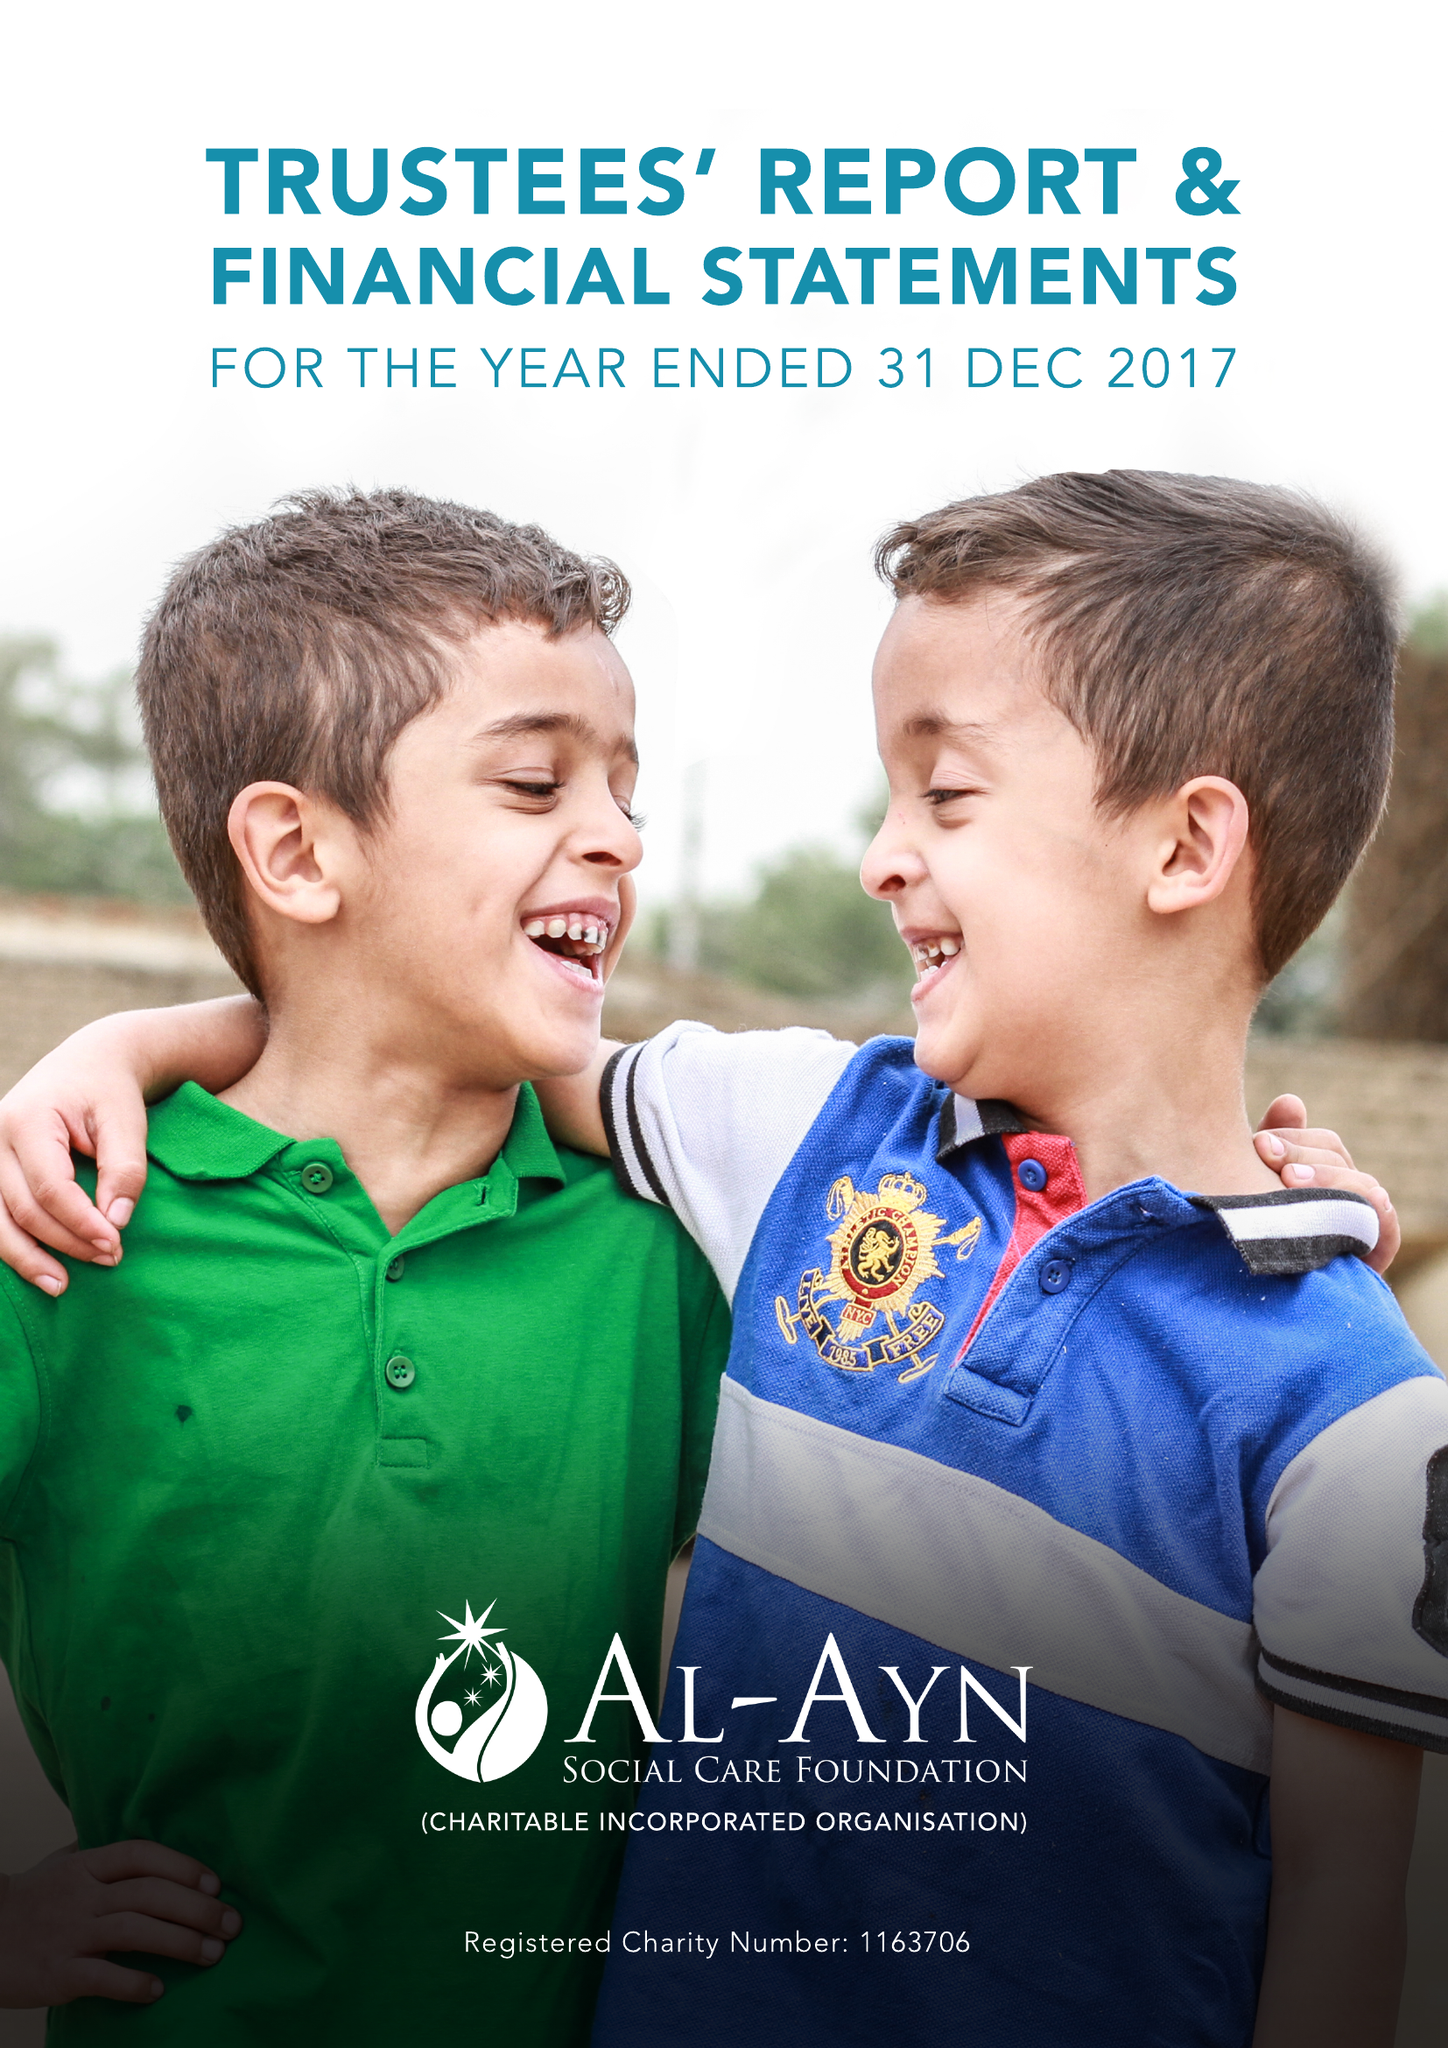What is the value for the address__postcode?
Answer the question using a single word or phrase. NW9 6NB 